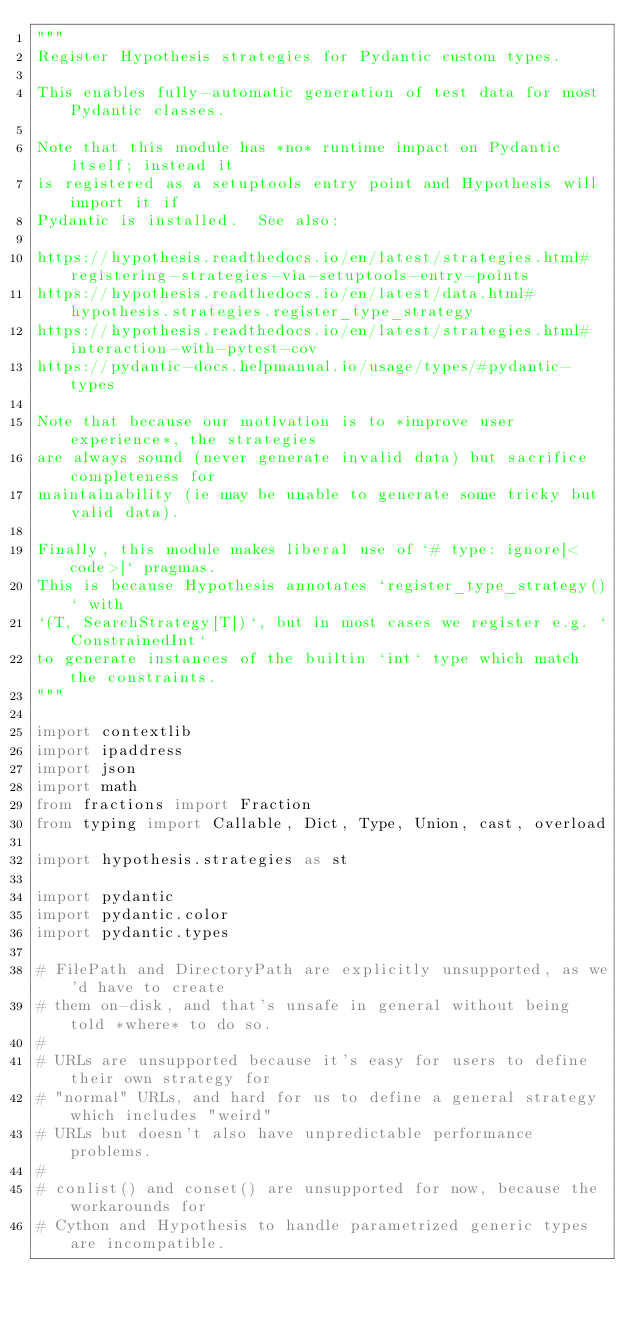Convert code to text. <code><loc_0><loc_0><loc_500><loc_500><_Python_>"""
Register Hypothesis strategies for Pydantic custom types.

This enables fully-automatic generation of test data for most Pydantic classes.

Note that this module has *no* runtime impact on Pydantic itself; instead it
is registered as a setuptools entry point and Hypothesis will import it if
Pydantic is installed.  See also:

https://hypothesis.readthedocs.io/en/latest/strategies.html#registering-strategies-via-setuptools-entry-points
https://hypothesis.readthedocs.io/en/latest/data.html#hypothesis.strategies.register_type_strategy
https://hypothesis.readthedocs.io/en/latest/strategies.html#interaction-with-pytest-cov
https://pydantic-docs.helpmanual.io/usage/types/#pydantic-types

Note that because our motivation is to *improve user experience*, the strategies
are always sound (never generate invalid data) but sacrifice completeness for
maintainability (ie may be unable to generate some tricky but valid data).

Finally, this module makes liberal use of `# type: ignore[<code>]` pragmas.
This is because Hypothesis annotates `register_type_strategy()` with
`(T, SearchStrategy[T])`, but in most cases we register e.g. `ConstrainedInt`
to generate instances of the builtin `int` type which match the constraints.
"""

import contextlib
import ipaddress
import json
import math
from fractions import Fraction
from typing import Callable, Dict, Type, Union, cast, overload

import hypothesis.strategies as st

import pydantic
import pydantic.color
import pydantic.types

# FilePath and DirectoryPath are explicitly unsupported, as we'd have to create
# them on-disk, and that's unsafe in general without being told *where* to do so.
#
# URLs are unsupported because it's easy for users to define their own strategy for
# "normal" URLs, and hard for us to define a general strategy which includes "weird"
# URLs but doesn't also have unpredictable performance problems.
#
# conlist() and conset() are unsupported for now, because the workarounds for
# Cython and Hypothesis to handle parametrized generic types are incompatible.</code> 